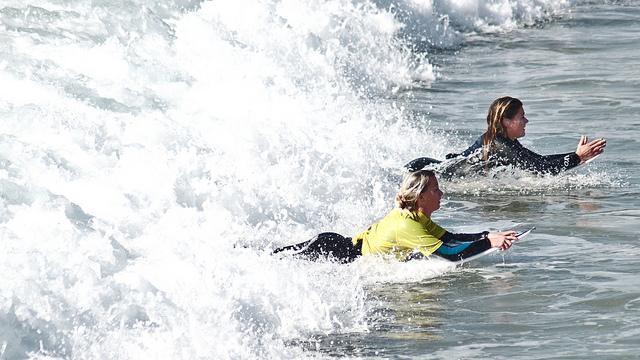How many people are in the picture?
Give a very brief answer. 2. How many cows are eating?
Give a very brief answer. 0. 